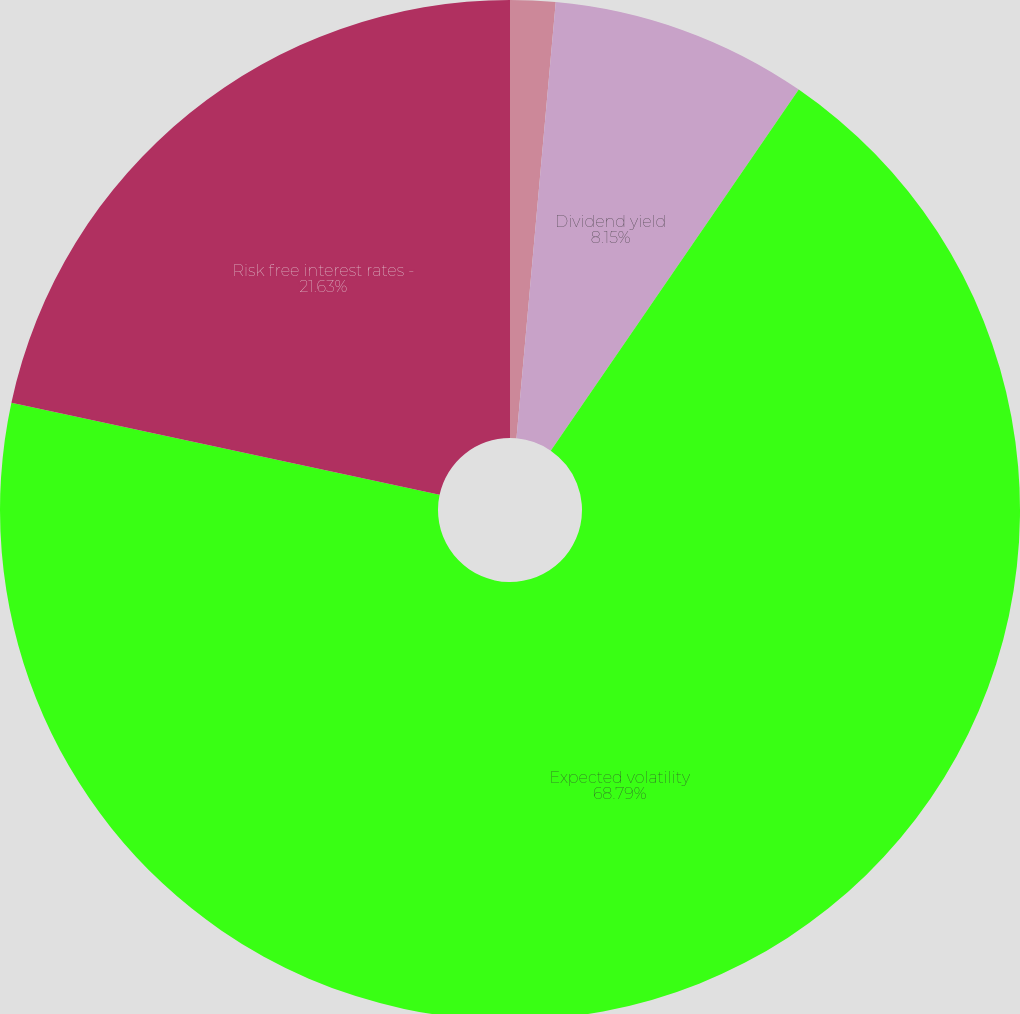Convert chart. <chart><loc_0><loc_0><loc_500><loc_500><pie_chart><fcel>Dividend<fcel>Dividend yield<fcel>Expected volatility<fcel>Risk free interest rates -<nl><fcel>1.43%<fcel>8.15%<fcel>68.8%<fcel>21.63%<nl></chart> 